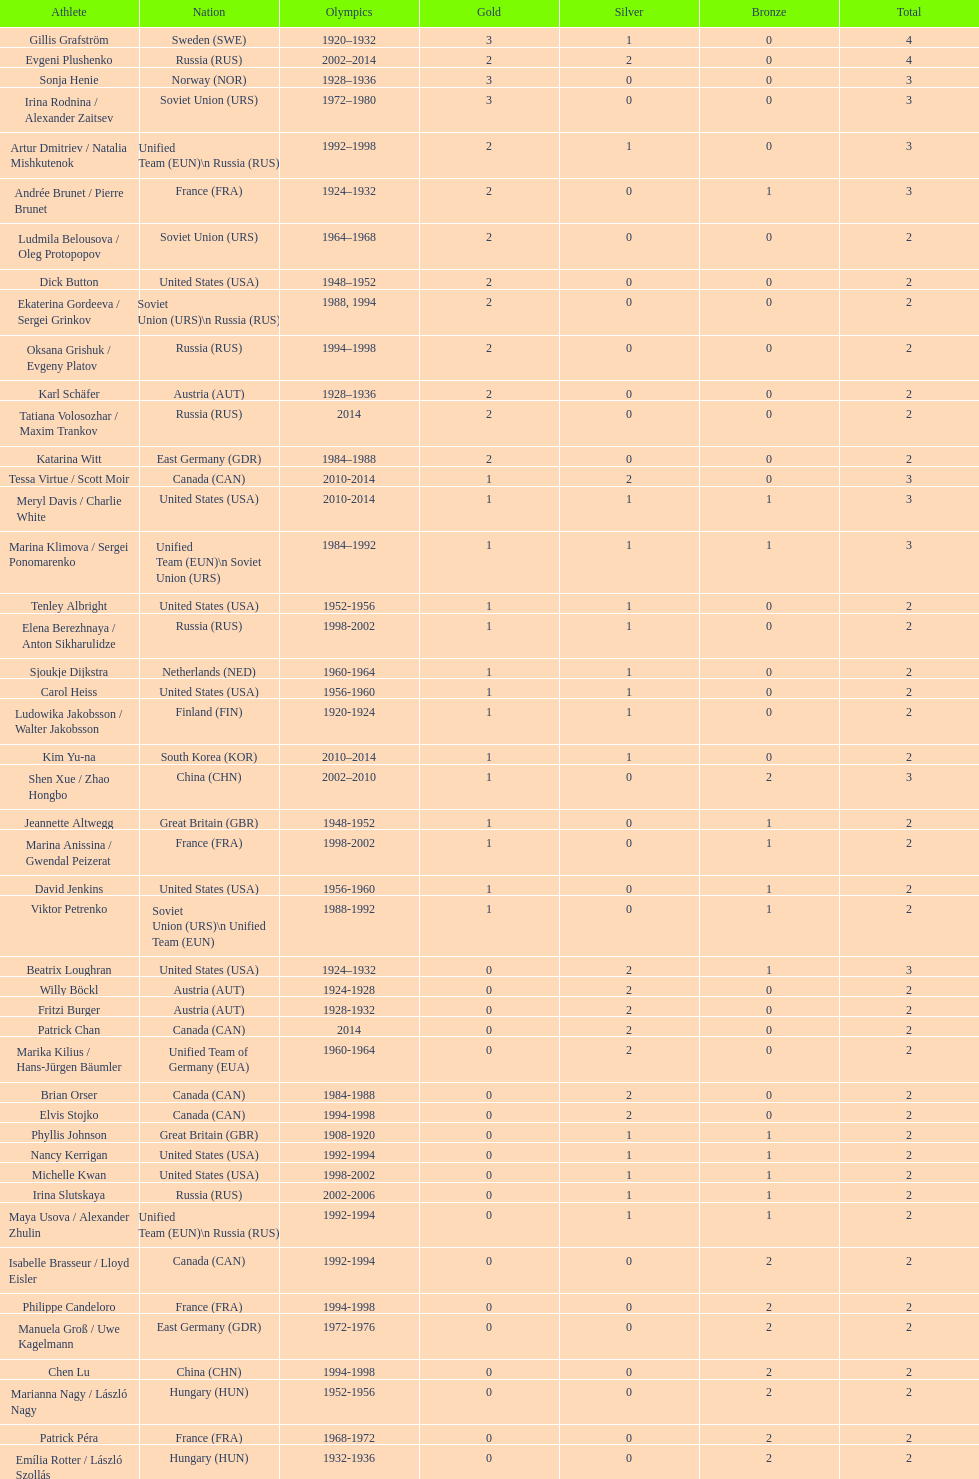What's the cumulative count of medals the united states has achieved in women's figure skating? 16. 